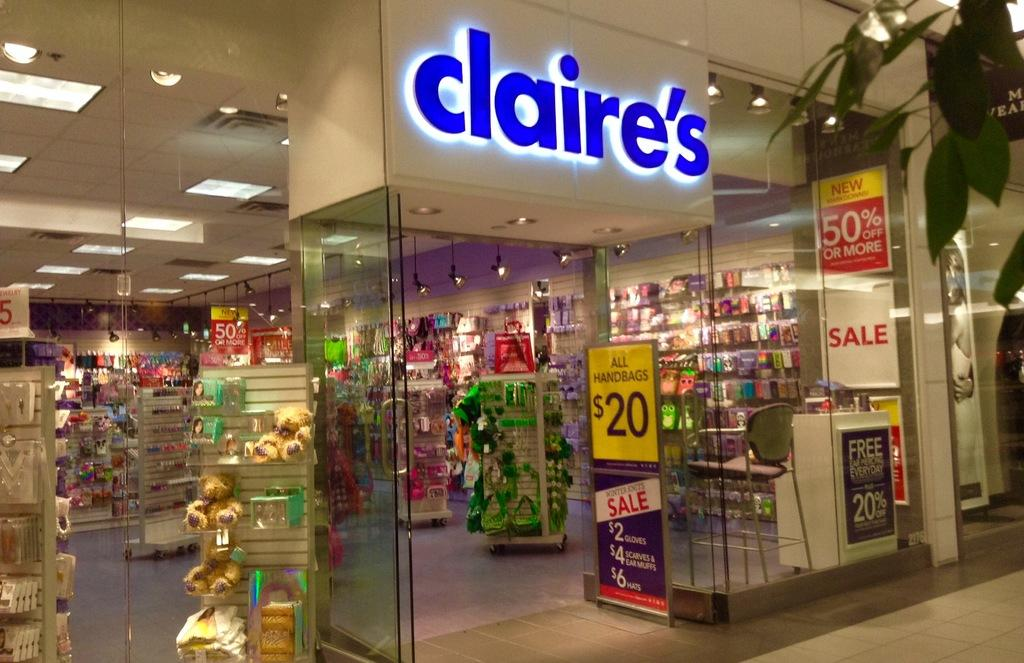Provide a one-sentence caption for the provided image. A claire's store in a mall advertising various sales at the entrance. 